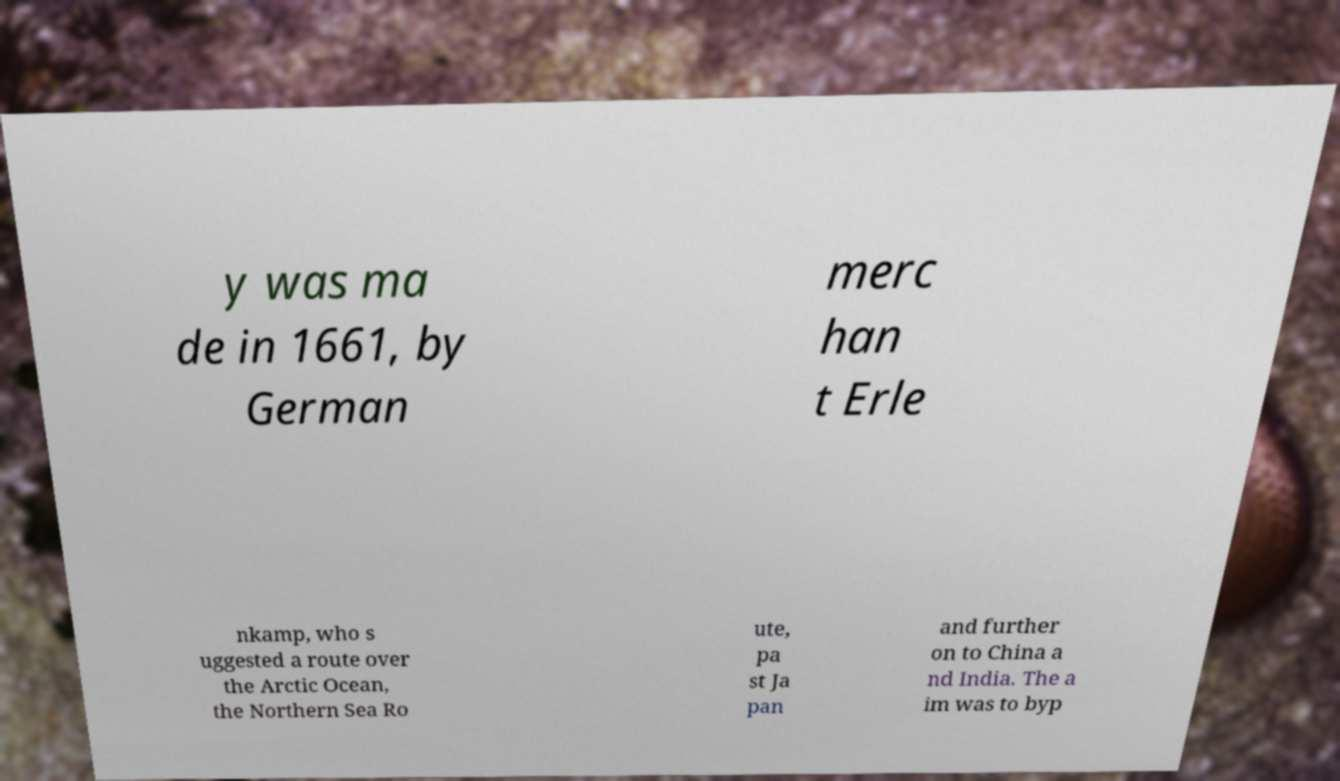There's text embedded in this image that I need extracted. Can you transcribe it verbatim? y was ma de in 1661, by German merc han t Erle nkamp, who s uggested a route over the Arctic Ocean, the Northern Sea Ro ute, pa st Ja pan and further on to China a nd India. The a im was to byp 